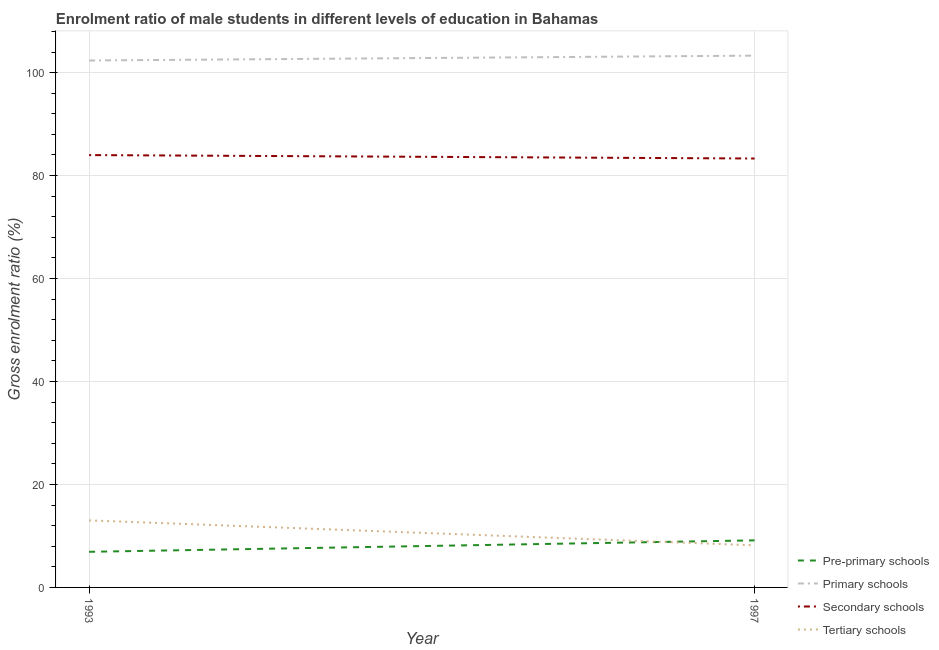How many different coloured lines are there?
Give a very brief answer. 4. What is the gross enrolment ratio(female) in secondary schools in 1993?
Your answer should be very brief. 83.98. Across all years, what is the maximum gross enrolment ratio(female) in tertiary schools?
Your answer should be compact. 13.02. Across all years, what is the minimum gross enrolment ratio(female) in secondary schools?
Your response must be concise. 83.31. In which year was the gross enrolment ratio(female) in tertiary schools maximum?
Give a very brief answer. 1993. What is the total gross enrolment ratio(female) in tertiary schools in the graph?
Give a very brief answer. 21.2. What is the difference between the gross enrolment ratio(female) in primary schools in 1993 and that in 1997?
Keep it short and to the point. -0.94. What is the difference between the gross enrolment ratio(female) in primary schools in 1993 and the gross enrolment ratio(female) in pre-primary schools in 1997?
Keep it short and to the point. 93.21. What is the average gross enrolment ratio(female) in primary schools per year?
Your answer should be very brief. 102.82. In the year 1993, what is the difference between the gross enrolment ratio(female) in tertiary schools and gross enrolment ratio(female) in secondary schools?
Provide a succinct answer. -70.95. What is the ratio of the gross enrolment ratio(female) in secondary schools in 1993 to that in 1997?
Offer a terse response. 1.01. In how many years, is the gross enrolment ratio(female) in tertiary schools greater than the average gross enrolment ratio(female) in tertiary schools taken over all years?
Your response must be concise. 1. Is it the case that in every year, the sum of the gross enrolment ratio(female) in secondary schools and gross enrolment ratio(female) in tertiary schools is greater than the sum of gross enrolment ratio(female) in primary schools and gross enrolment ratio(female) in pre-primary schools?
Your answer should be very brief. No. Is it the case that in every year, the sum of the gross enrolment ratio(female) in pre-primary schools and gross enrolment ratio(female) in primary schools is greater than the gross enrolment ratio(female) in secondary schools?
Give a very brief answer. Yes. Is the gross enrolment ratio(female) in tertiary schools strictly greater than the gross enrolment ratio(female) in pre-primary schools over the years?
Offer a terse response. No. Is the gross enrolment ratio(female) in primary schools strictly less than the gross enrolment ratio(female) in pre-primary schools over the years?
Give a very brief answer. No. How many years are there in the graph?
Provide a succinct answer. 2. Does the graph contain any zero values?
Give a very brief answer. No. What is the title of the graph?
Your response must be concise. Enrolment ratio of male students in different levels of education in Bahamas. Does "Energy" appear as one of the legend labels in the graph?
Make the answer very short. No. What is the label or title of the Y-axis?
Offer a terse response. Gross enrolment ratio (%). What is the Gross enrolment ratio (%) in Pre-primary schools in 1993?
Provide a short and direct response. 6.92. What is the Gross enrolment ratio (%) of Primary schools in 1993?
Provide a short and direct response. 102.35. What is the Gross enrolment ratio (%) of Secondary schools in 1993?
Offer a terse response. 83.98. What is the Gross enrolment ratio (%) of Tertiary schools in 1993?
Ensure brevity in your answer.  13.02. What is the Gross enrolment ratio (%) in Pre-primary schools in 1997?
Ensure brevity in your answer.  9.14. What is the Gross enrolment ratio (%) of Primary schools in 1997?
Ensure brevity in your answer.  103.3. What is the Gross enrolment ratio (%) of Secondary schools in 1997?
Your response must be concise. 83.31. What is the Gross enrolment ratio (%) of Tertiary schools in 1997?
Your answer should be compact. 8.18. Across all years, what is the maximum Gross enrolment ratio (%) of Pre-primary schools?
Keep it short and to the point. 9.14. Across all years, what is the maximum Gross enrolment ratio (%) of Primary schools?
Your response must be concise. 103.3. Across all years, what is the maximum Gross enrolment ratio (%) of Secondary schools?
Keep it short and to the point. 83.98. Across all years, what is the maximum Gross enrolment ratio (%) in Tertiary schools?
Your answer should be compact. 13.02. Across all years, what is the minimum Gross enrolment ratio (%) of Pre-primary schools?
Your answer should be very brief. 6.92. Across all years, what is the minimum Gross enrolment ratio (%) of Primary schools?
Provide a succinct answer. 102.35. Across all years, what is the minimum Gross enrolment ratio (%) of Secondary schools?
Give a very brief answer. 83.31. Across all years, what is the minimum Gross enrolment ratio (%) in Tertiary schools?
Your answer should be very brief. 8.18. What is the total Gross enrolment ratio (%) in Pre-primary schools in the graph?
Keep it short and to the point. 16.06. What is the total Gross enrolment ratio (%) of Primary schools in the graph?
Your response must be concise. 205.65. What is the total Gross enrolment ratio (%) in Secondary schools in the graph?
Your response must be concise. 167.29. What is the total Gross enrolment ratio (%) of Tertiary schools in the graph?
Your response must be concise. 21.2. What is the difference between the Gross enrolment ratio (%) of Pre-primary schools in 1993 and that in 1997?
Ensure brevity in your answer.  -2.22. What is the difference between the Gross enrolment ratio (%) in Primary schools in 1993 and that in 1997?
Your answer should be compact. -0.94. What is the difference between the Gross enrolment ratio (%) of Secondary schools in 1993 and that in 1997?
Provide a short and direct response. 0.67. What is the difference between the Gross enrolment ratio (%) of Tertiary schools in 1993 and that in 1997?
Give a very brief answer. 4.85. What is the difference between the Gross enrolment ratio (%) in Pre-primary schools in 1993 and the Gross enrolment ratio (%) in Primary schools in 1997?
Provide a succinct answer. -96.38. What is the difference between the Gross enrolment ratio (%) of Pre-primary schools in 1993 and the Gross enrolment ratio (%) of Secondary schools in 1997?
Your answer should be very brief. -76.39. What is the difference between the Gross enrolment ratio (%) of Pre-primary schools in 1993 and the Gross enrolment ratio (%) of Tertiary schools in 1997?
Offer a very short reply. -1.26. What is the difference between the Gross enrolment ratio (%) in Primary schools in 1993 and the Gross enrolment ratio (%) in Secondary schools in 1997?
Provide a succinct answer. 19.04. What is the difference between the Gross enrolment ratio (%) in Primary schools in 1993 and the Gross enrolment ratio (%) in Tertiary schools in 1997?
Keep it short and to the point. 94.18. What is the difference between the Gross enrolment ratio (%) in Secondary schools in 1993 and the Gross enrolment ratio (%) in Tertiary schools in 1997?
Provide a short and direct response. 75.8. What is the average Gross enrolment ratio (%) of Pre-primary schools per year?
Make the answer very short. 8.03. What is the average Gross enrolment ratio (%) in Primary schools per year?
Offer a terse response. 102.82. What is the average Gross enrolment ratio (%) of Secondary schools per year?
Give a very brief answer. 83.64. What is the average Gross enrolment ratio (%) in Tertiary schools per year?
Offer a very short reply. 10.6. In the year 1993, what is the difference between the Gross enrolment ratio (%) of Pre-primary schools and Gross enrolment ratio (%) of Primary schools?
Keep it short and to the point. -95.43. In the year 1993, what is the difference between the Gross enrolment ratio (%) of Pre-primary schools and Gross enrolment ratio (%) of Secondary schools?
Provide a succinct answer. -77.06. In the year 1993, what is the difference between the Gross enrolment ratio (%) of Pre-primary schools and Gross enrolment ratio (%) of Tertiary schools?
Keep it short and to the point. -6.11. In the year 1993, what is the difference between the Gross enrolment ratio (%) in Primary schools and Gross enrolment ratio (%) in Secondary schools?
Your response must be concise. 18.37. In the year 1993, what is the difference between the Gross enrolment ratio (%) in Primary schools and Gross enrolment ratio (%) in Tertiary schools?
Ensure brevity in your answer.  89.33. In the year 1993, what is the difference between the Gross enrolment ratio (%) in Secondary schools and Gross enrolment ratio (%) in Tertiary schools?
Your answer should be very brief. 70.95. In the year 1997, what is the difference between the Gross enrolment ratio (%) of Pre-primary schools and Gross enrolment ratio (%) of Primary schools?
Provide a short and direct response. -94.15. In the year 1997, what is the difference between the Gross enrolment ratio (%) of Pre-primary schools and Gross enrolment ratio (%) of Secondary schools?
Offer a terse response. -74.17. In the year 1997, what is the difference between the Gross enrolment ratio (%) in Pre-primary schools and Gross enrolment ratio (%) in Tertiary schools?
Ensure brevity in your answer.  0.97. In the year 1997, what is the difference between the Gross enrolment ratio (%) of Primary schools and Gross enrolment ratio (%) of Secondary schools?
Your answer should be very brief. 19.98. In the year 1997, what is the difference between the Gross enrolment ratio (%) of Primary schools and Gross enrolment ratio (%) of Tertiary schools?
Provide a succinct answer. 95.12. In the year 1997, what is the difference between the Gross enrolment ratio (%) of Secondary schools and Gross enrolment ratio (%) of Tertiary schools?
Offer a very short reply. 75.13. What is the ratio of the Gross enrolment ratio (%) in Pre-primary schools in 1993 to that in 1997?
Ensure brevity in your answer.  0.76. What is the ratio of the Gross enrolment ratio (%) in Primary schools in 1993 to that in 1997?
Ensure brevity in your answer.  0.99. What is the ratio of the Gross enrolment ratio (%) of Secondary schools in 1993 to that in 1997?
Your answer should be compact. 1.01. What is the ratio of the Gross enrolment ratio (%) in Tertiary schools in 1993 to that in 1997?
Provide a short and direct response. 1.59. What is the difference between the highest and the second highest Gross enrolment ratio (%) in Pre-primary schools?
Offer a very short reply. 2.22. What is the difference between the highest and the second highest Gross enrolment ratio (%) in Primary schools?
Make the answer very short. 0.94. What is the difference between the highest and the second highest Gross enrolment ratio (%) of Secondary schools?
Your answer should be very brief. 0.67. What is the difference between the highest and the second highest Gross enrolment ratio (%) of Tertiary schools?
Your answer should be compact. 4.85. What is the difference between the highest and the lowest Gross enrolment ratio (%) of Pre-primary schools?
Your answer should be very brief. 2.22. What is the difference between the highest and the lowest Gross enrolment ratio (%) in Primary schools?
Make the answer very short. 0.94. What is the difference between the highest and the lowest Gross enrolment ratio (%) of Secondary schools?
Your answer should be very brief. 0.67. What is the difference between the highest and the lowest Gross enrolment ratio (%) in Tertiary schools?
Your answer should be very brief. 4.85. 